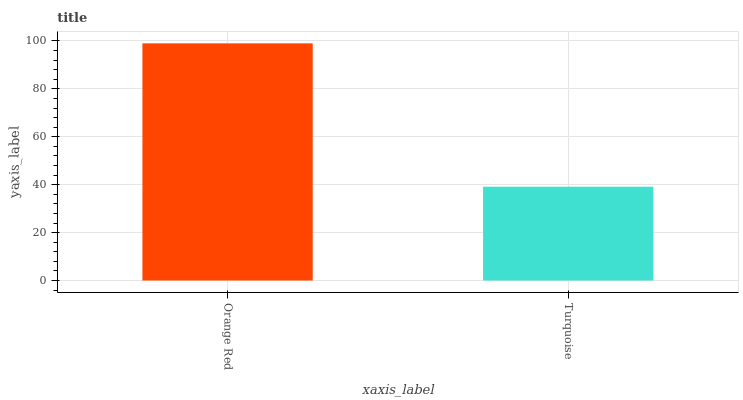Is Turquoise the minimum?
Answer yes or no. Yes. Is Orange Red the maximum?
Answer yes or no. Yes. Is Turquoise the maximum?
Answer yes or no. No. Is Orange Red greater than Turquoise?
Answer yes or no. Yes. Is Turquoise less than Orange Red?
Answer yes or no. Yes. Is Turquoise greater than Orange Red?
Answer yes or no. No. Is Orange Red less than Turquoise?
Answer yes or no. No. Is Orange Red the high median?
Answer yes or no. Yes. Is Turquoise the low median?
Answer yes or no. Yes. Is Turquoise the high median?
Answer yes or no. No. Is Orange Red the low median?
Answer yes or no. No. 